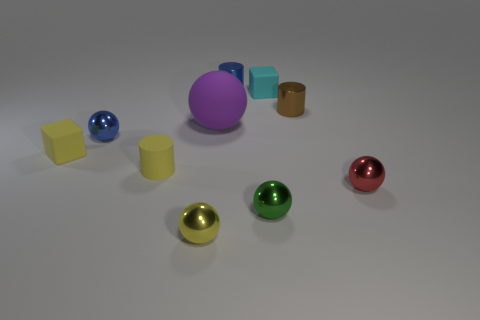Are there fewer matte cubes to the left of the purple matte thing than tiny blue cylinders behind the blue cylinder?
Your answer should be very brief. No. What shape is the small rubber thing that is on the right side of the blue thing that is to the right of the tiny matte cylinder?
Provide a succinct answer. Cube. How many other things are there of the same material as the tiny cyan block?
Offer a very short reply. 3. Is there any other thing that is the same size as the green shiny thing?
Give a very brief answer. Yes. Is the number of small things greater than the number of tiny green spheres?
Offer a terse response. Yes. What size is the rubber object in front of the yellow thing that is on the left side of the metallic sphere that is behind the small yellow matte block?
Your answer should be very brief. Small. Is the size of the red thing the same as the blue metallic ball that is in front of the rubber ball?
Make the answer very short. Yes. Are there fewer tiny yellow shiny objects that are right of the small green shiny sphere than large blue metal cubes?
Make the answer very short. No. How many blocks are the same color as the large sphere?
Keep it short and to the point. 0. Are there fewer cubes than red spheres?
Give a very brief answer. No. 